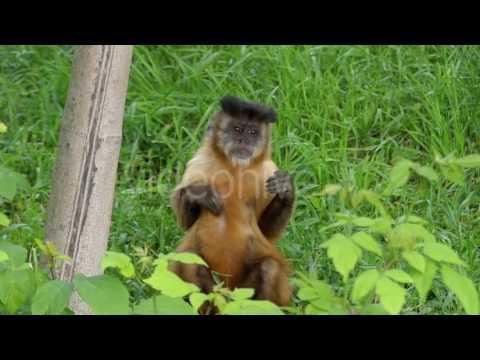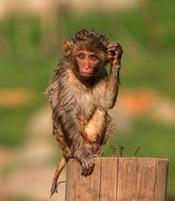The first image is the image on the left, the second image is the image on the right. Considering the images on both sides, is "At least one ape is showing its teeth." valid? Answer yes or no. No. 